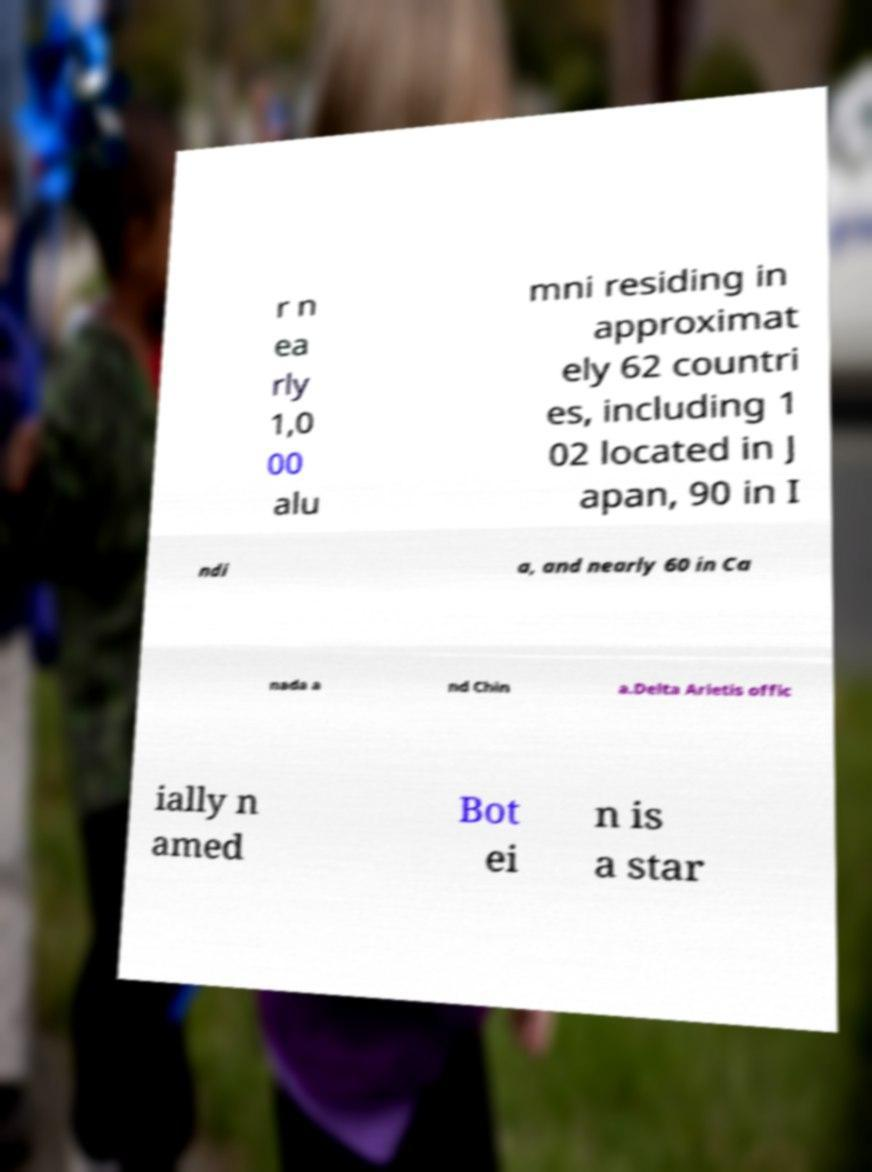Please read and relay the text visible in this image. What does it say? r n ea rly 1,0 00 alu mni residing in approximat ely 62 countri es, including 1 02 located in J apan, 90 in I ndi a, and nearly 60 in Ca nada a nd Chin a.Delta Arietis offic ially n amed Bot ei n is a star 